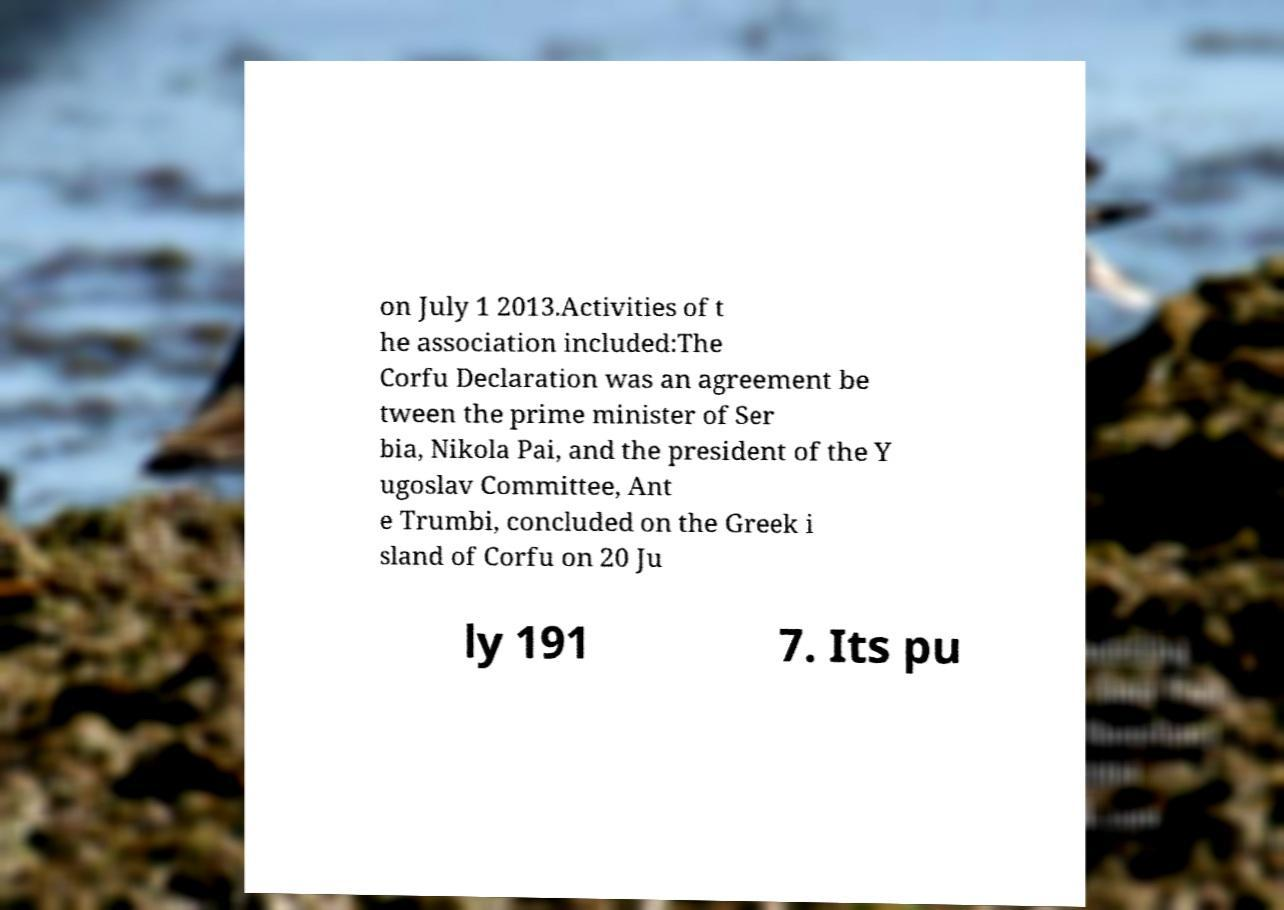Can you read and provide the text displayed in the image?This photo seems to have some interesting text. Can you extract and type it out for me? on July 1 2013.Activities of t he association included:The Corfu Declaration was an agreement be tween the prime minister of Ser bia, Nikola Pai, and the president of the Y ugoslav Committee, Ant e Trumbi, concluded on the Greek i sland of Corfu on 20 Ju ly 191 7. Its pu 